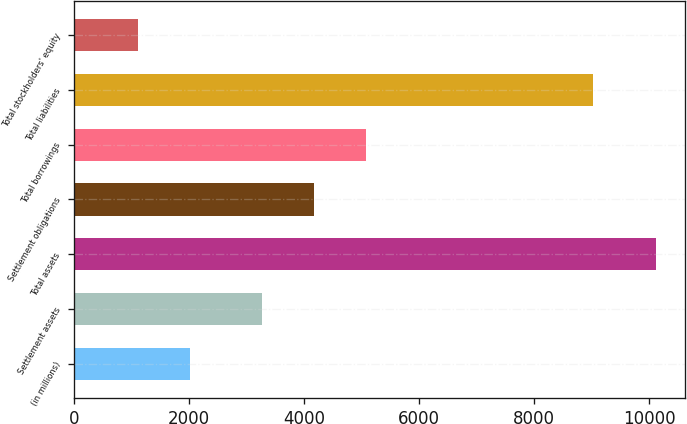<chart> <loc_0><loc_0><loc_500><loc_500><bar_chart><fcel>(in millions)<fcel>Settlement assets<fcel>Total assets<fcel>Settlement obligations<fcel>Total borrowings<fcel>Total liabilities<fcel>Total stockholders' equity<nl><fcel>2013<fcel>3270.4<fcel>10121.3<fcel>4172.06<fcel>5073.72<fcel>9016.6<fcel>1104.7<nl></chart> 